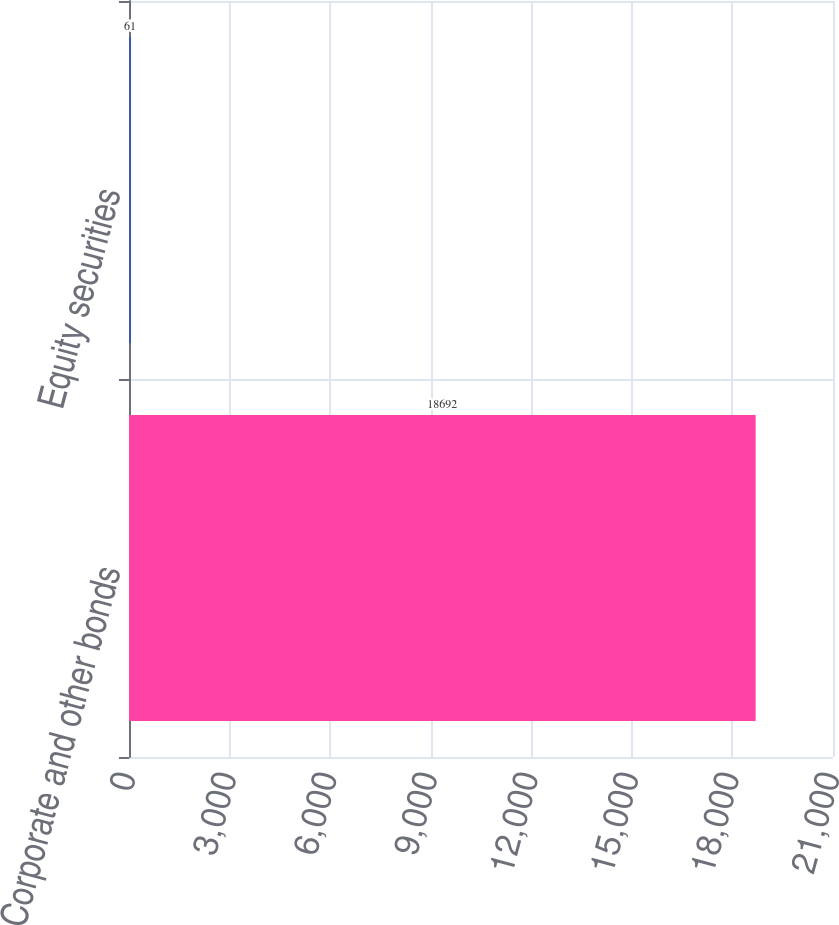<chart> <loc_0><loc_0><loc_500><loc_500><bar_chart><fcel>Corporate and other bonds<fcel>Equity securities<nl><fcel>18692<fcel>61<nl></chart> 